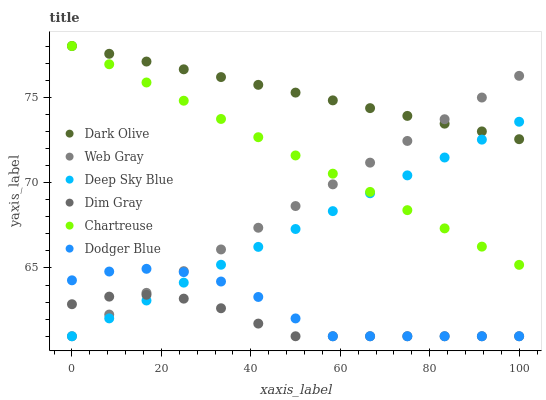Does Dim Gray have the minimum area under the curve?
Answer yes or no. Yes. Does Dark Olive have the maximum area under the curve?
Answer yes or no. Yes. Does Chartreuse have the minimum area under the curve?
Answer yes or no. No. Does Chartreuse have the maximum area under the curve?
Answer yes or no. No. Is Deep Sky Blue the smoothest?
Answer yes or no. Yes. Is Dodger Blue the roughest?
Answer yes or no. Yes. Is Dark Olive the smoothest?
Answer yes or no. No. Is Dark Olive the roughest?
Answer yes or no. No. Does Dim Gray have the lowest value?
Answer yes or no. Yes. Does Chartreuse have the lowest value?
Answer yes or no. No. Does Chartreuse have the highest value?
Answer yes or no. Yes. Does Web Gray have the highest value?
Answer yes or no. No. Is Dim Gray less than Dark Olive?
Answer yes or no. Yes. Is Dark Olive greater than Dodger Blue?
Answer yes or no. Yes. Does Web Gray intersect Chartreuse?
Answer yes or no. Yes. Is Web Gray less than Chartreuse?
Answer yes or no. No. Is Web Gray greater than Chartreuse?
Answer yes or no. No. Does Dim Gray intersect Dark Olive?
Answer yes or no. No. 